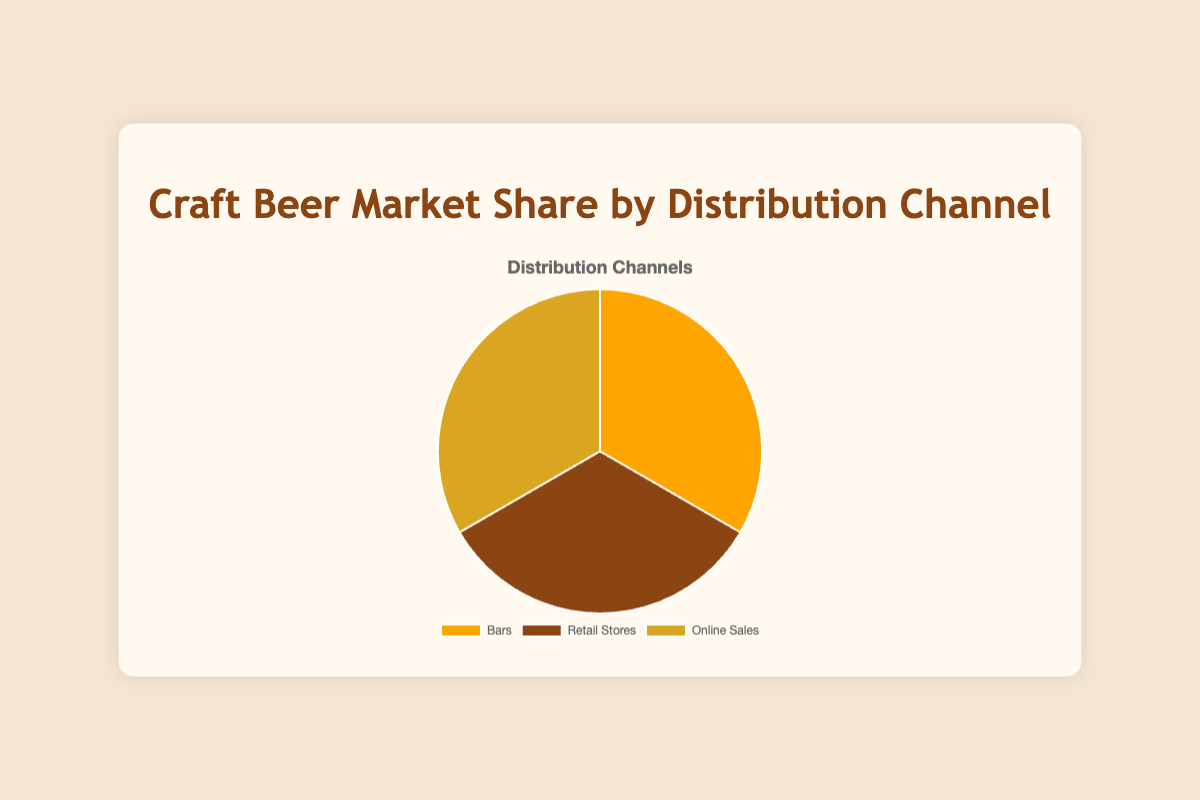What percentage of the market share is held by bars? The pie chart shows that bars hold 100% of the market share in their distribution channel.
Answer: 100% Which distribution channel has the smallest market share? The chart indicates that each distribution channel (Bars, Retail Stores, Online Sales) holds an equal 100% market share within their respective categories. Therefore, none of the channels have a smaller market share.
Answer: None Is the market share of Retail Stores more, less, or equal to the market share of Online Sales? The chart shows that both Retail Stores and Online Sales have an equal market share of 100%.
Answer: Equal How do the visual colors differentiate between distribution channels? The pie chart uses different colors to distinguish distribution channels: Bars in orange, Retail Stores in brown, and Online Sales in golden yellow.
Answer: Orange, Brown, Golden Yellow What is the sum of the market share percentages for all distribution channels combined? Since the chart displays market shares separately for each distribution channel and doesn’t combine them, summing the separate 100% for each channel adds up to 300%.
Answer: 300% If one distribution channel’s market share could be divided equally between two new channels, what would be the market share of each new channel? If a single distribution channel's 100% market share is divided equally, each new channel would have 50% market share.
Answer: 50% Compare the colors used in the chart - which colors represent Bars and Retail Stores? The pie chart shows Bars in orange and Retail Stores in brown.
Answer: Orange and Brown Which distribution channel has a golden hue in the pie chart? The chart indicates that the Online Sales distribution channel is represented in a golden yellow color.
Answer: Online Sales in golden yellow 